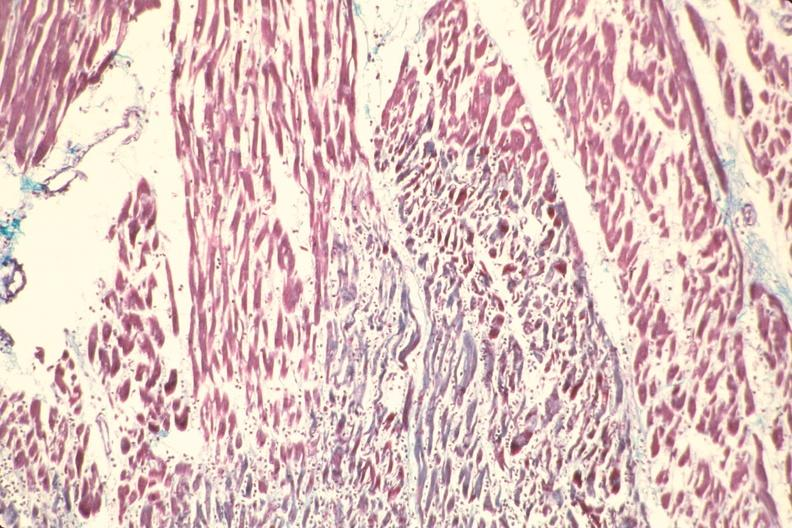what does this image show?
Answer the question using a single word or phrase. Heart 